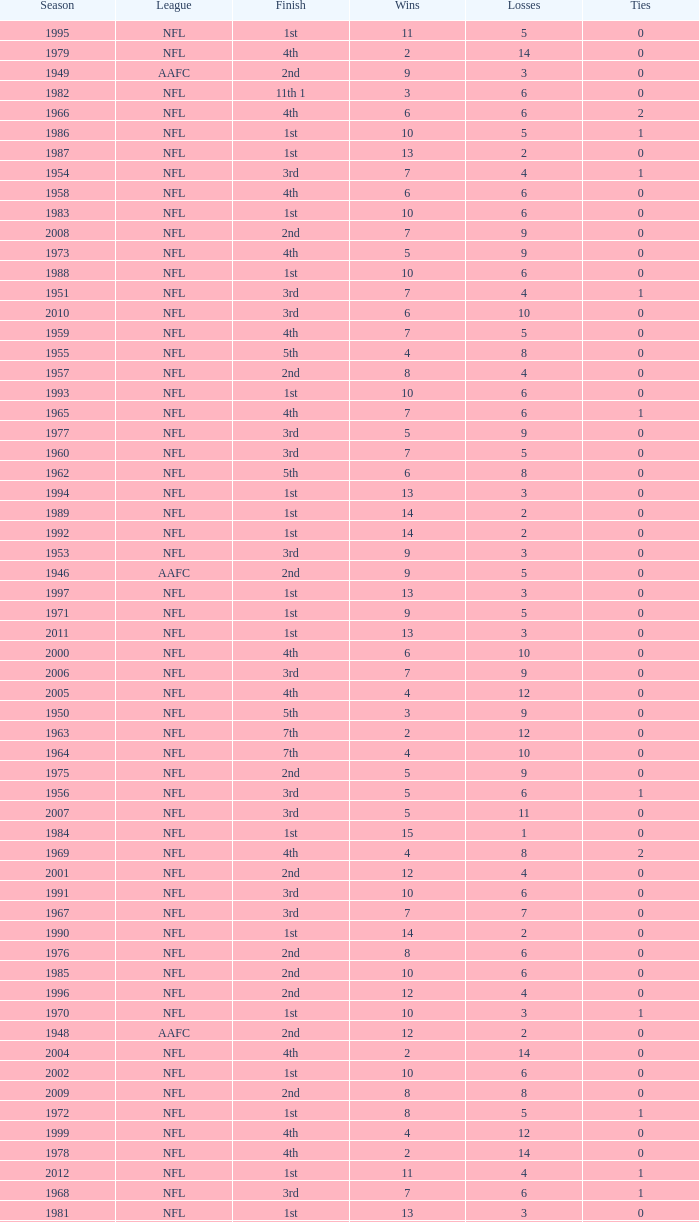What league had a finish of 2nd and 3 losses? AAFC. 